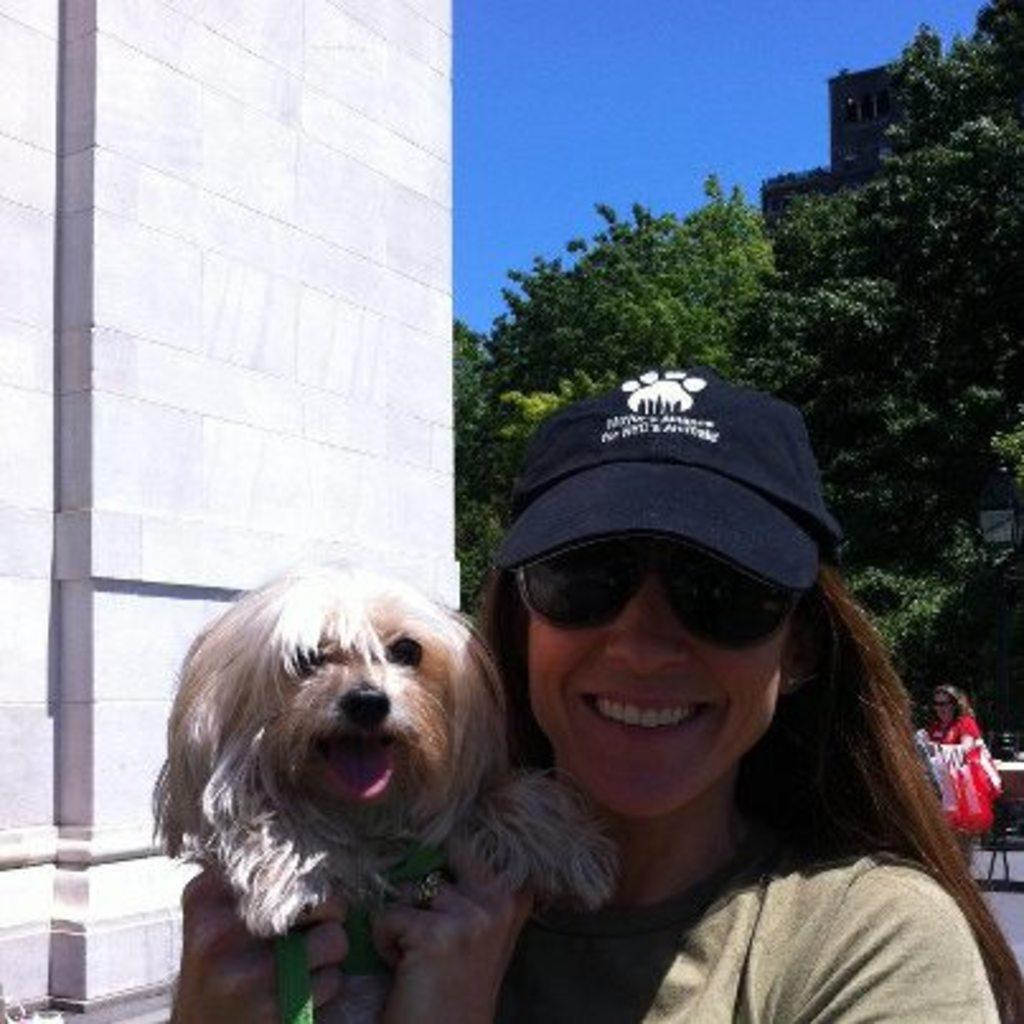Who is present in the image? There is a woman in the image. What other living creature is present in the image? There is a dog in the image. What can be seen in the background of the image? There are trees and a building in the background of the image. What type of stocking is the woman wearing in the image? There is no information about the woman's clothing, including stockings, in the image. 